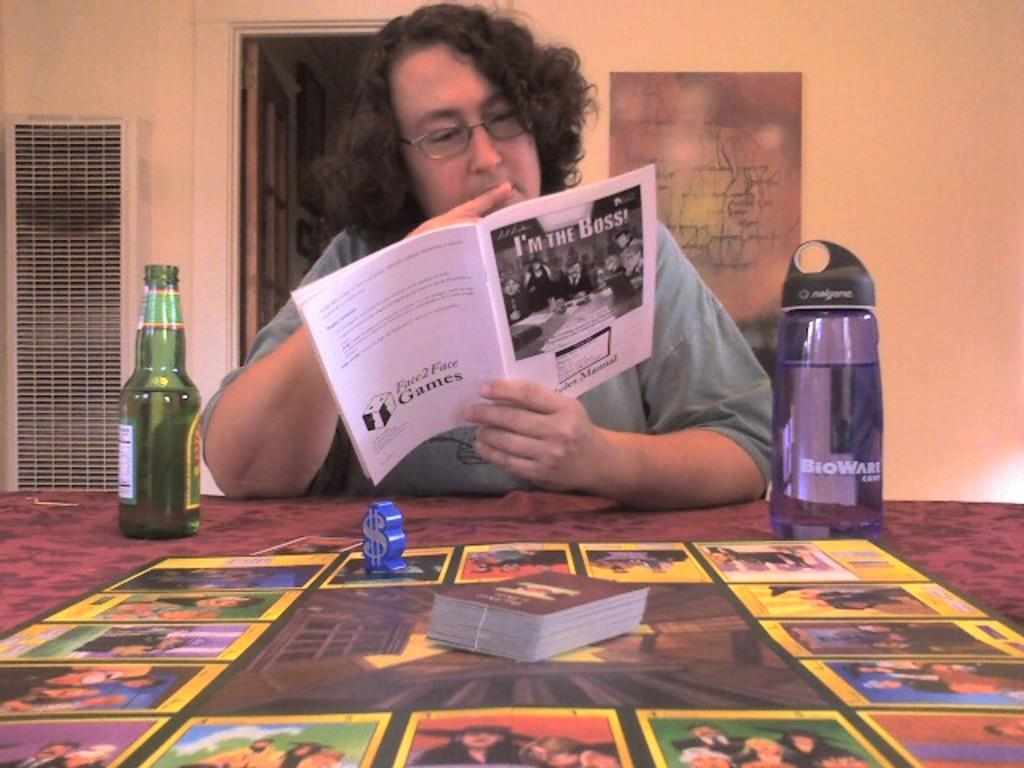<image>
Relay a brief, clear account of the picture shown. A lady reading a book called I'm the Boss with a beer and water bottle beside her. 